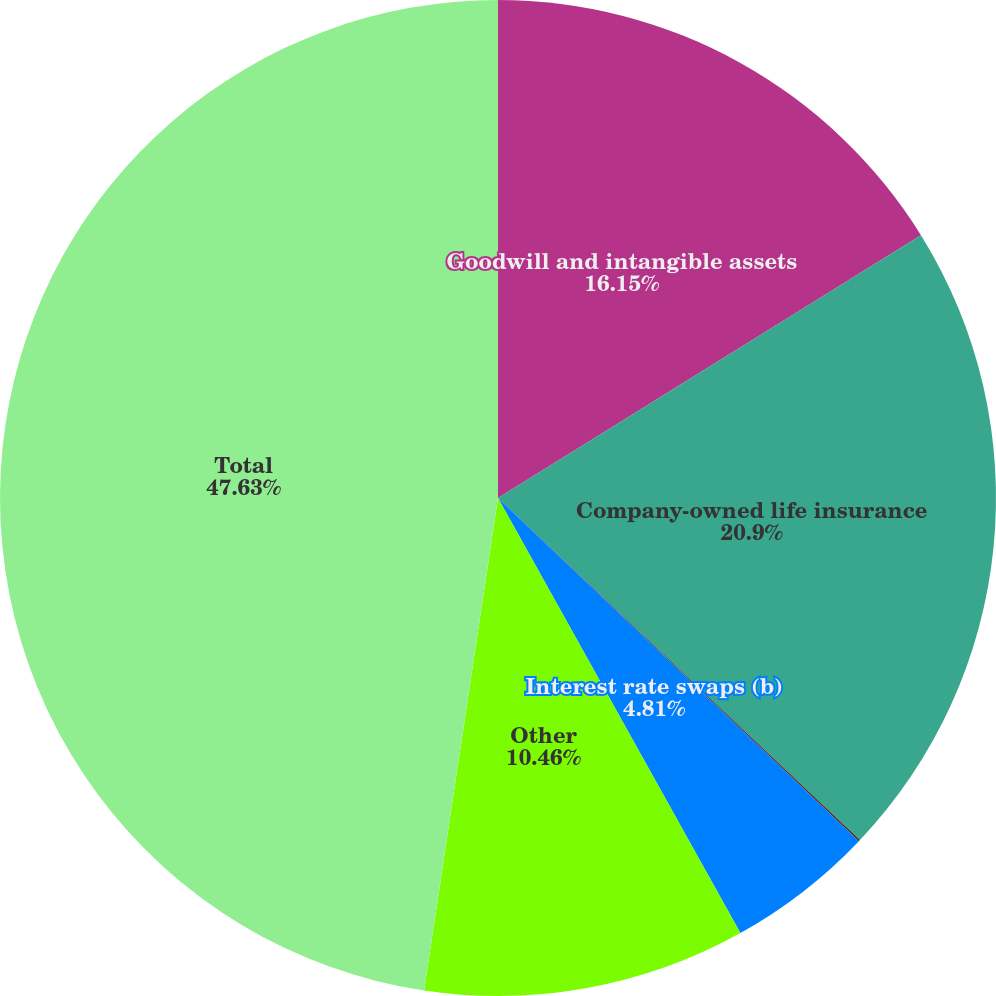<chart> <loc_0><loc_0><loc_500><loc_500><pie_chart><fcel>Goodwill and intangible assets<fcel>Company-owned life insurance<fcel>Pension asset<fcel>Interest rate swaps (b)<fcel>Other<fcel>Total<nl><fcel>16.15%<fcel>20.9%<fcel>0.05%<fcel>4.81%<fcel>10.46%<fcel>47.63%<nl></chart> 